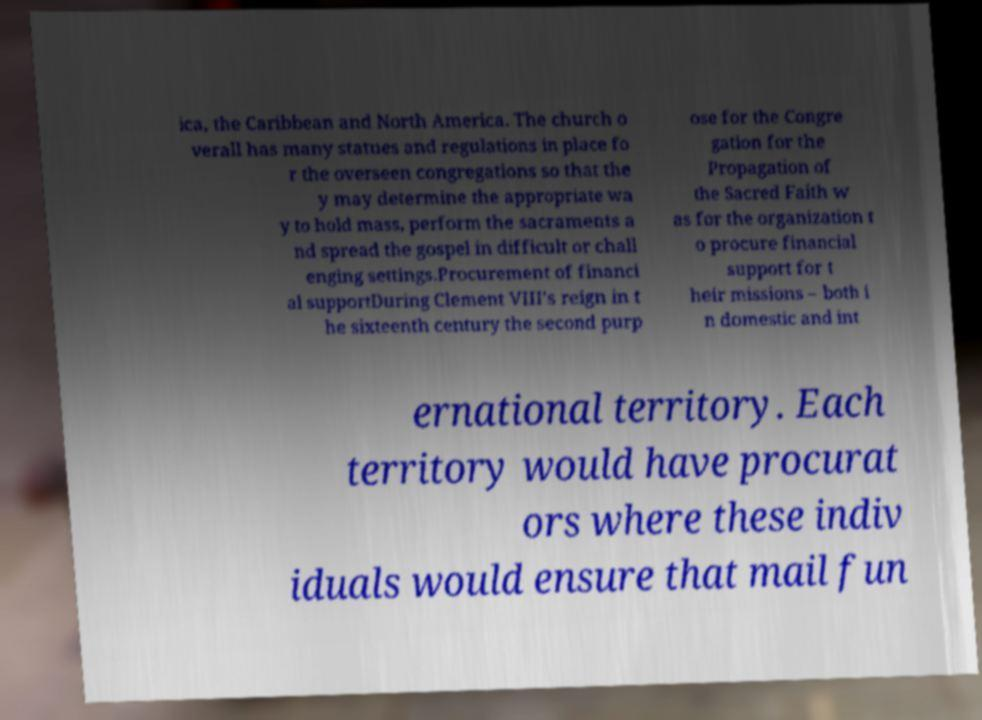Please read and relay the text visible in this image. What does it say? ica, the Caribbean and North America. The church o verall has many statues and regulations in place fo r the overseen congregations so that the y may determine the appropriate wa y to hold mass, perform the sacraments a nd spread the gospel in difficult or chall enging settings.Procurement of financi al supportDuring Clement VIII’s reign in t he sixteenth century the second purp ose for the Congre gation for the Propagation of the Sacred Faith w as for the organization t o procure financial support for t heir missions – both i n domestic and int ernational territory. Each territory would have procurat ors where these indiv iduals would ensure that mail fun 